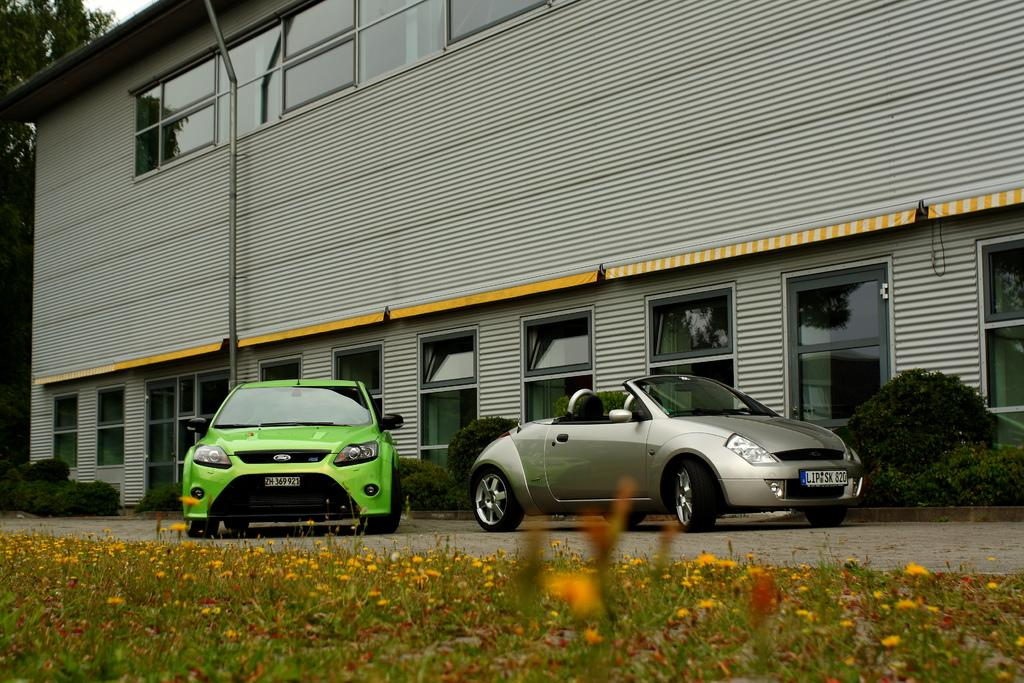What can be seen on the road in the image? There are vehicles on the road in the image. What type of vegetation is present in the image? There are plants, flowers, and trees in the image. What is visible in the background of the image? There is a building and the sky visible in the background of the image. What type of stamp can be seen on the building in the image? There is no stamp present on the building in the image. What type of fog can be seen in the image? There is no fog present in the image. 